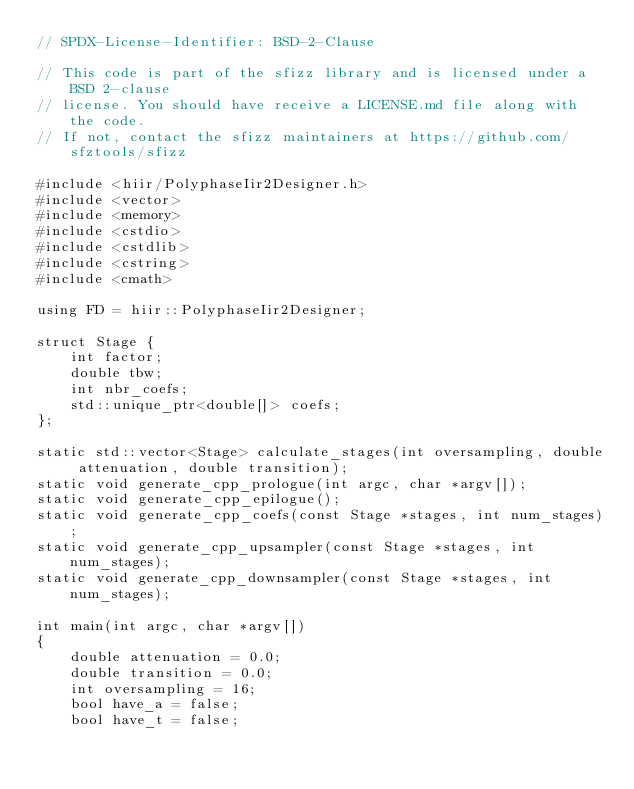Convert code to text. <code><loc_0><loc_0><loc_500><loc_500><_C++_>// SPDX-License-Identifier: BSD-2-Clause

// This code is part of the sfizz library and is licensed under a BSD 2-clause
// license. You should have receive a LICENSE.md file along with the code.
// If not, contact the sfizz maintainers at https://github.com/sfztools/sfizz

#include <hiir/PolyphaseIir2Designer.h>
#include <vector>
#include <memory>
#include <cstdio>
#include <cstdlib>
#include <cstring>
#include <cmath>

using FD = hiir::PolyphaseIir2Designer;

struct Stage {
    int factor;
    double tbw;
    int nbr_coefs;
    std::unique_ptr<double[]> coefs;
};

static std::vector<Stage> calculate_stages(int oversampling, double attenuation, double transition);
static void generate_cpp_prologue(int argc, char *argv[]);
static void generate_cpp_epilogue();
static void generate_cpp_coefs(const Stage *stages, int num_stages);
static void generate_cpp_upsampler(const Stage *stages, int num_stages);
static void generate_cpp_downsampler(const Stage *stages, int num_stages);

int main(int argc, char *argv[])
{
    double attenuation = 0.0;
    double transition = 0.0;
    int oversampling = 16;
    bool have_a = false;
    bool have_t = false;
</code> 